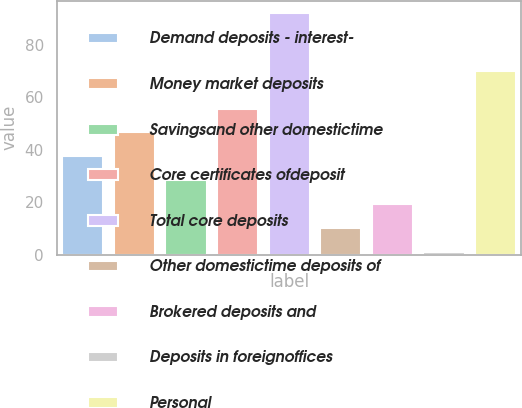Convert chart. <chart><loc_0><loc_0><loc_500><loc_500><bar_chart><fcel>Demand deposits - interest-<fcel>Money market deposits<fcel>Savingsand other domestictime<fcel>Core certificates ofdeposit<fcel>Total core deposits<fcel>Other domestictime deposits of<fcel>Brokered deposits and<fcel>Deposits in foreignoffices<fcel>Personal<nl><fcel>37.4<fcel>46.5<fcel>28.3<fcel>55.6<fcel>92<fcel>10.1<fcel>19.2<fcel>1<fcel>70<nl></chart> 